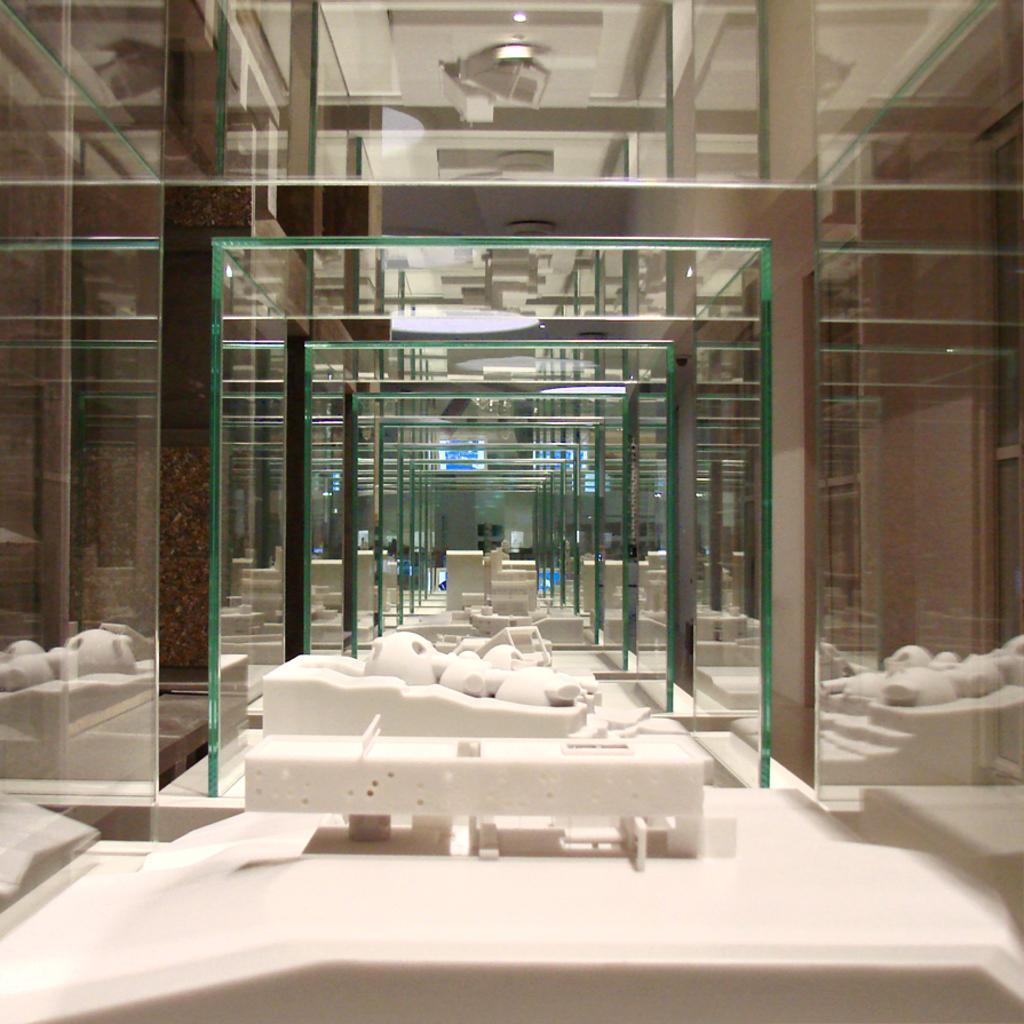What can be seen on the path in the image? There are objects on the path in the image. What is located on the left side of the objects? There are mirrors on the left side of the objects in the image. What is on the right side of the objects? There are other things on the right side of the objects in the image. What type of lighting is visible in the image? Ceiling lights are visible at the top of the image. Where is the cattle meeting taking place in the image? There is no cattle or meeting present in the image. 